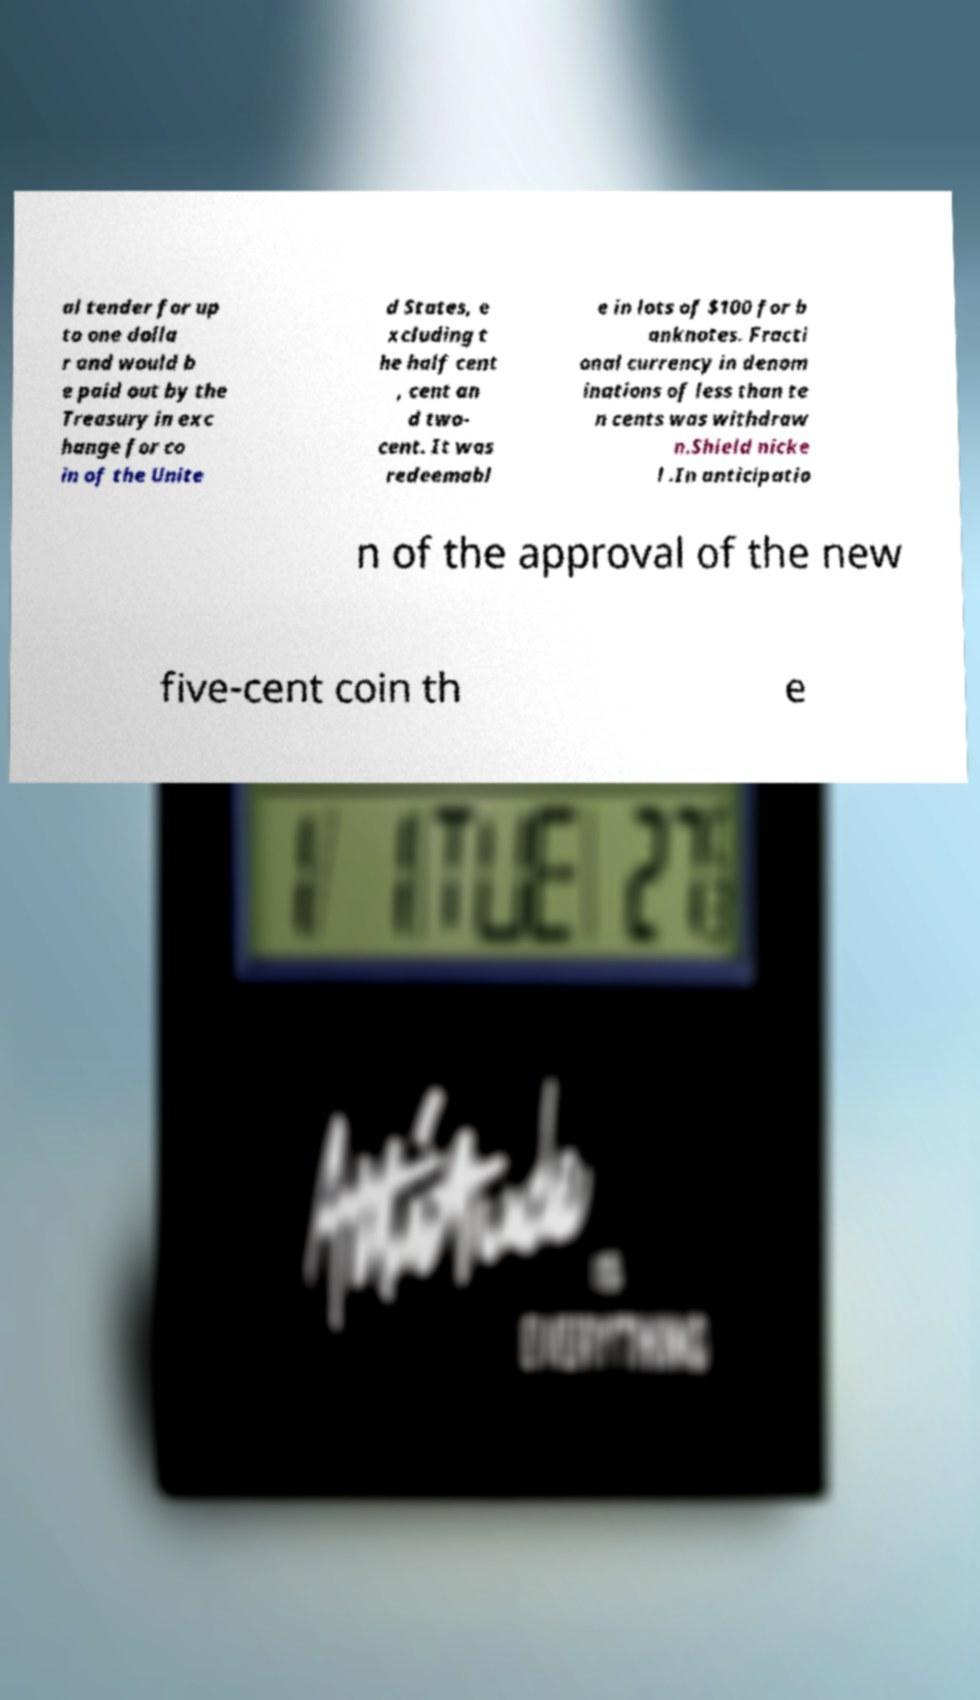Could you assist in decoding the text presented in this image and type it out clearly? al tender for up to one dolla r and would b e paid out by the Treasury in exc hange for co in of the Unite d States, e xcluding t he half cent , cent an d two- cent. It was redeemabl e in lots of $100 for b anknotes. Fracti onal currency in denom inations of less than te n cents was withdraw n.Shield nicke l .In anticipatio n of the approval of the new five-cent coin th e 